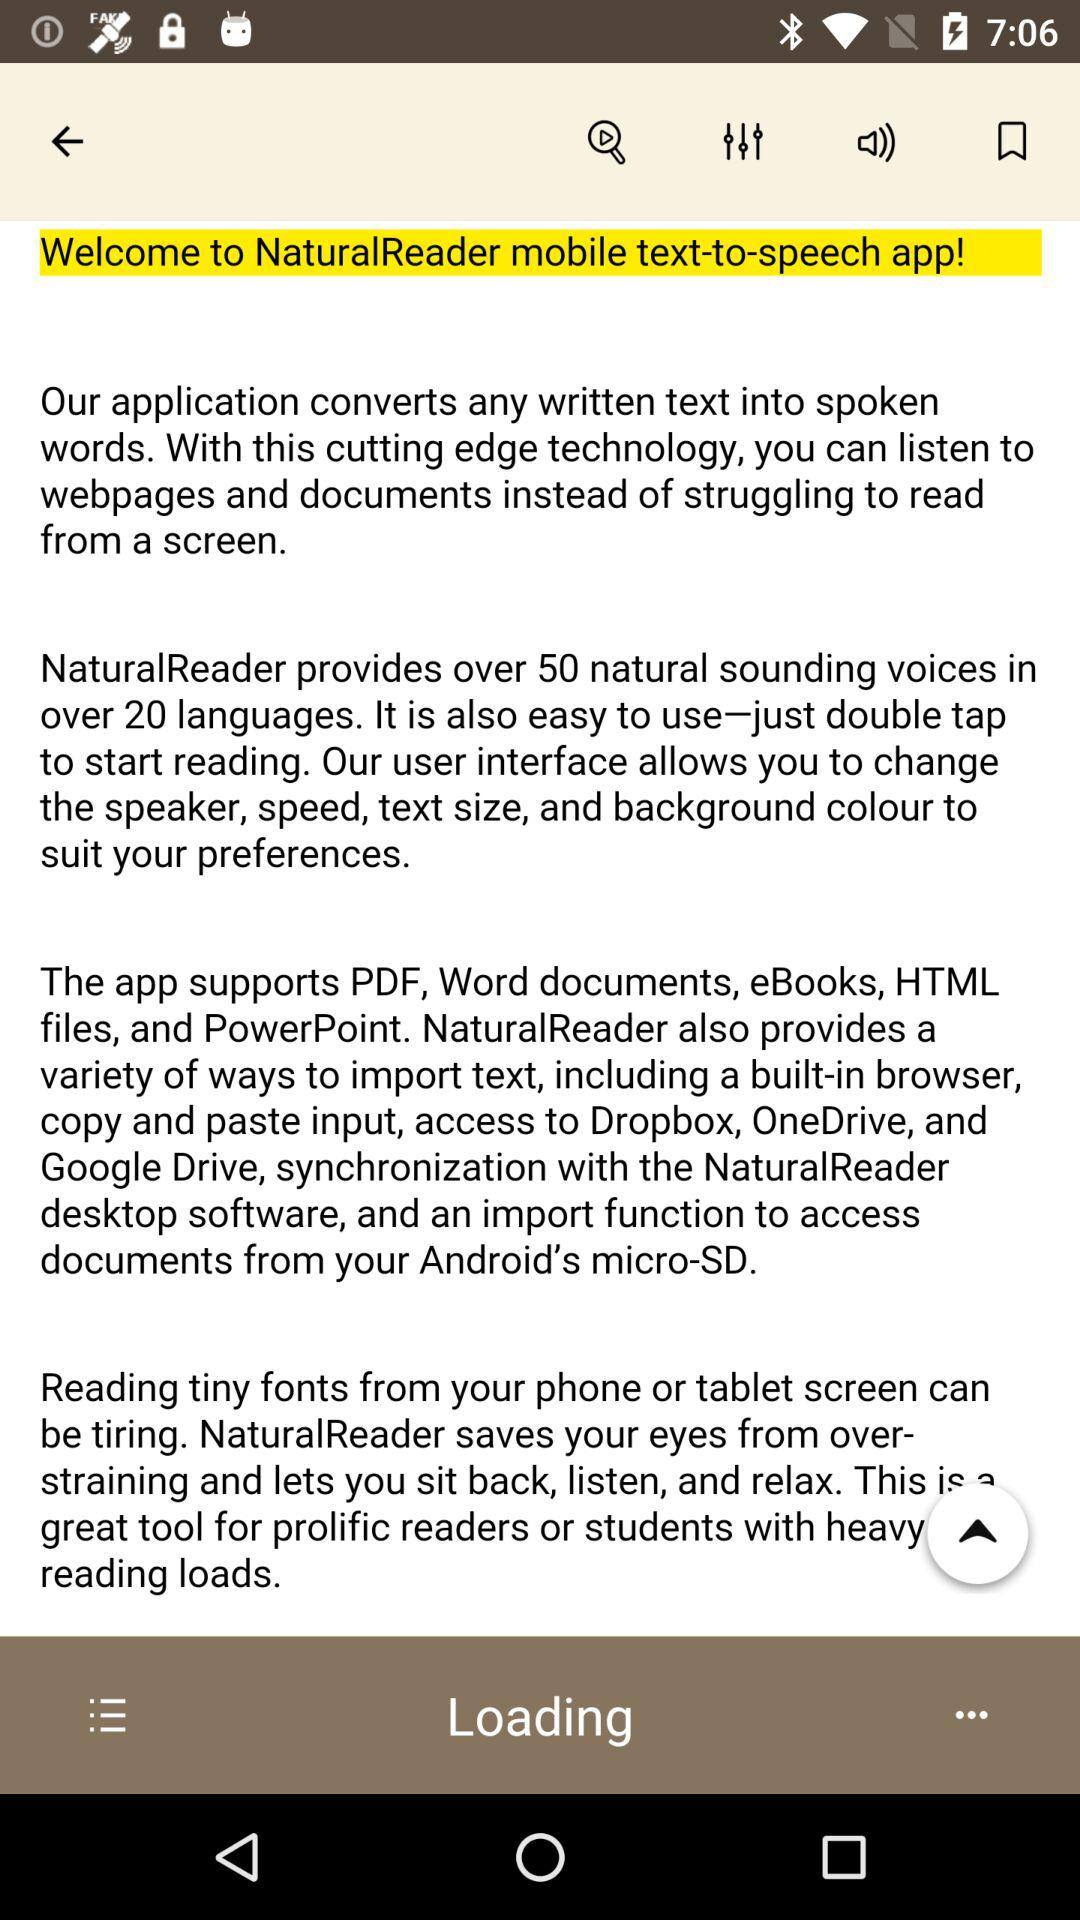What is the name of the mobile text-to-speech app? The name of the mobile text-to-speech app is "NaturalReader". 